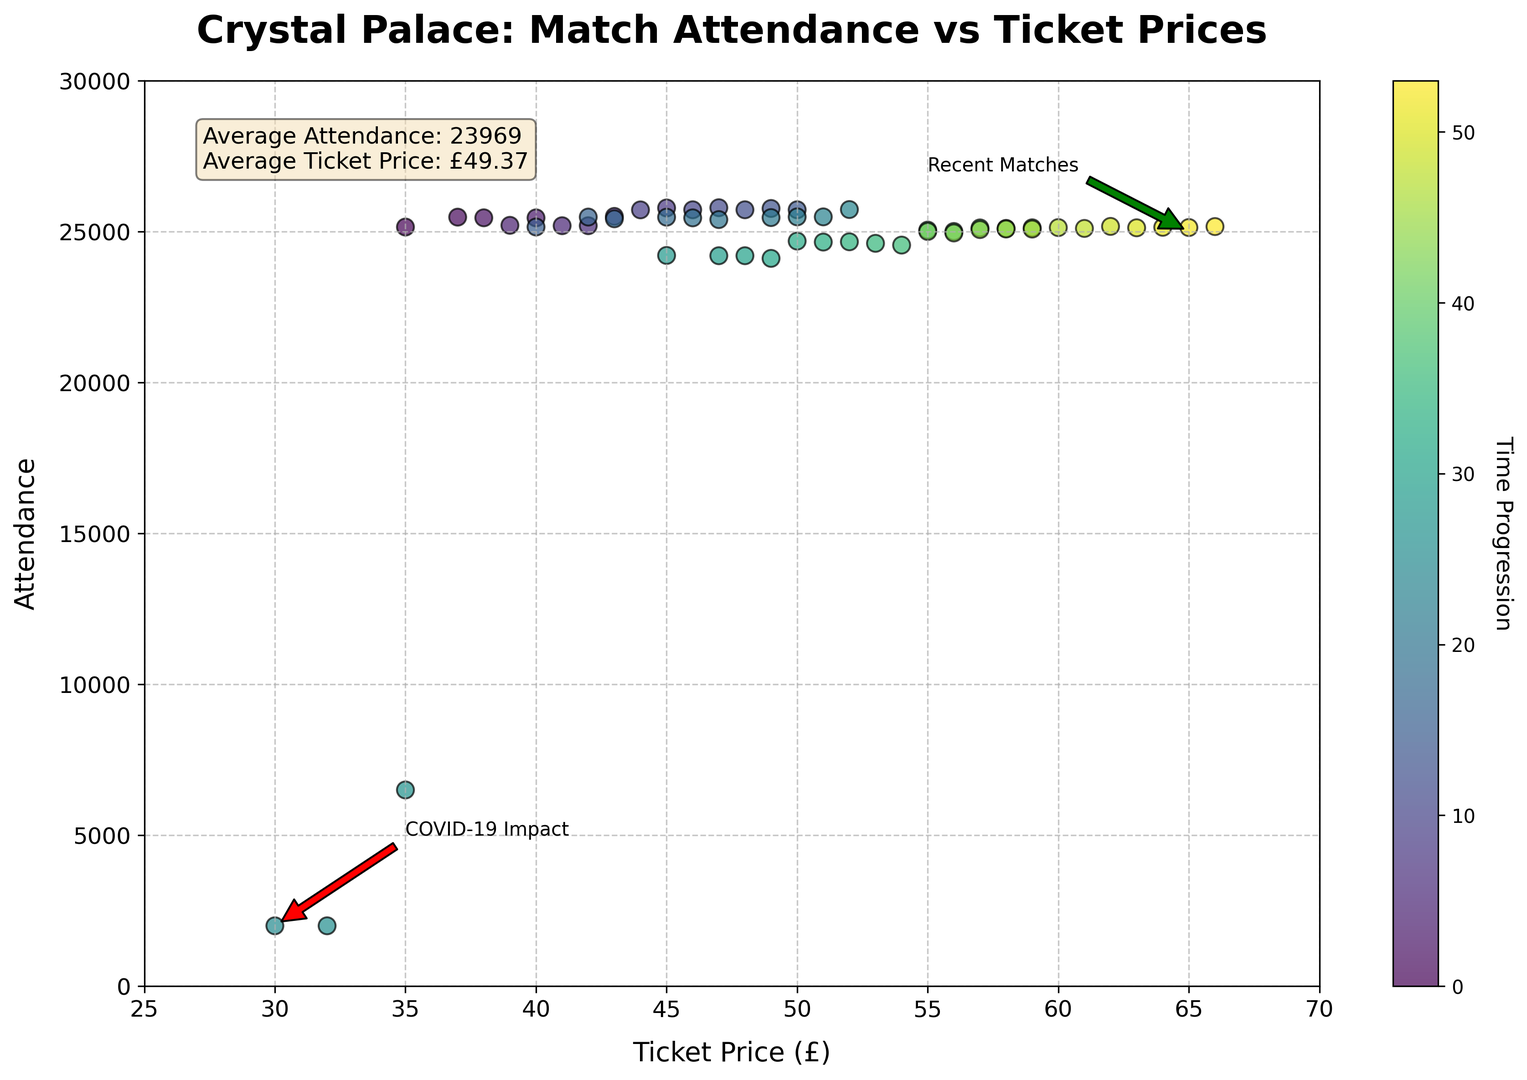What is the average match attendance during the last two seasons? To find the average attendance during the last two seasons, identify the matches that fall into those seasons (2021-2022 and 2022-2023), sum their attendance values, and divide by the number of matches. From the data, the attendance values for these seasons are (24208, 24199, 24199, 24111, 24684, 24651, 24660, 24609, 24551, 25047, 25002, 25120, 25104, 25124, 25002, 24953, 25065, 25084, 25082, 25131, 25103, 25170, 25124, 25141, 25133, 25165). Summing these and dividing by 26 gives (653460 / 26) ≈ 25133.
Answer: 25133 During which match was the lowest attendance recorded, and what was the ticket price for that match? Identify the match with the lowest attendance by looking at the scatter plot. The match with an attendance of 2000 is explicitly annotated with "COVID-19 Impact" at a ticket price of £30. Cross-check with the data to verify. The matches on 2020-09-26 and 2020-12-13 had the lowest attendance of 2000.
Answer: Matches on 2020-09-26 and 2020-12-13, £30 How does the average ticket price compare between the first season (2018-2019) and the last season (2022-2023)? Calculate the average ticket price for each season. For 2018-2019, the ticket prices are (35, 37, 38, 40, 39, 41, 42, 43, 45, 44, 46, 47, 48, 49, 50). Their sum is 704, and the average is 704/15 ≈ 47. For 2022-2023, the ticket prices are (55, 56, 57, 58, 59, 60, 61, 62, 63, 64, 65, 66). Their sum is 726, and the average is 726/12 ≈ 60.5.
Answer: 47 for 2018-2019, 60.5 for 2022-2023 Is there a trend in attendance as ticket prices increase? By observing the scatter plot, one can see that as the ticket prices increase, the majority of the attendance values tend to cluster around 25000, with exceptions due to extraordinary circumstances labeled on the plot. General consistency means no clear increasing or decreasing trend but a stable attendance of around 25000 despite price increments.
Answer: Stable around 25000 Which season experienced a significant dip in attendance due to external circumstances, and how is it visually represented? The scatter plot annotations indicate a significant dip around the 2020 season with an attendance of 2000 due to "COVID-19 Impact." This is distinctly marked with a label and an arrow pointing to the attendance value of 2000 and a ticket price of £30.
Answer: 2020 season, marked with "COVID-19 Impact" annotation What is the variance in ticket prices over the entire period? To find the variance, calculate the mean ticket price, then compute the squared difference from the mean for each ticket price, sum them up, and divide by the number of data points. Mean ticket price over all periods = 47.47. Calculated using: [(35-47.47)^2 + (37-47.47)^2 + ... + (66-47.47)^2]/56 ≈ 124.5.
Answer: 124.5 